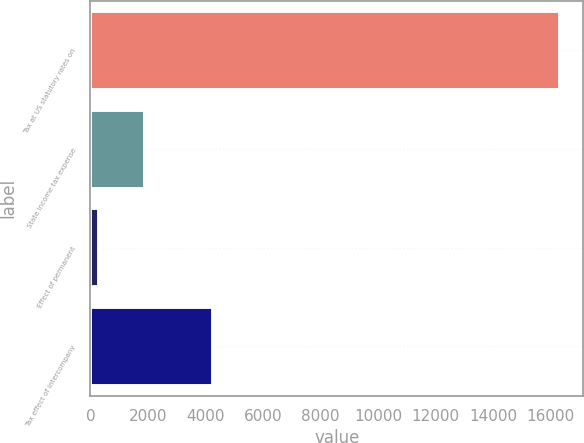Convert chart to OTSL. <chart><loc_0><loc_0><loc_500><loc_500><bar_chart><fcel>Tax at US statutory rates on<fcel>State income tax expense<fcel>Effect of permanent<fcel>Tax effect of intercompany<nl><fcel>16326<fcel>1899<fcel>296<fcel>4272<nl></chart> 